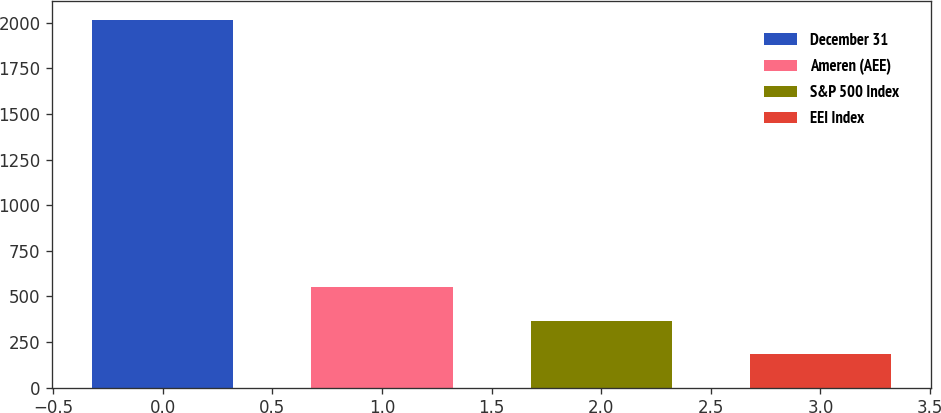<chart> <loc_0><loc_0><loc_500><loc_500><bar_chart><fcel>December 31<fcel>Ameren (AEE)<fcel>S&P 500 Index<fcel>EEI Index<nl><fcel>2017<fcel>550.35<fcel>367.02<fcel>183.69<nl></chart> 